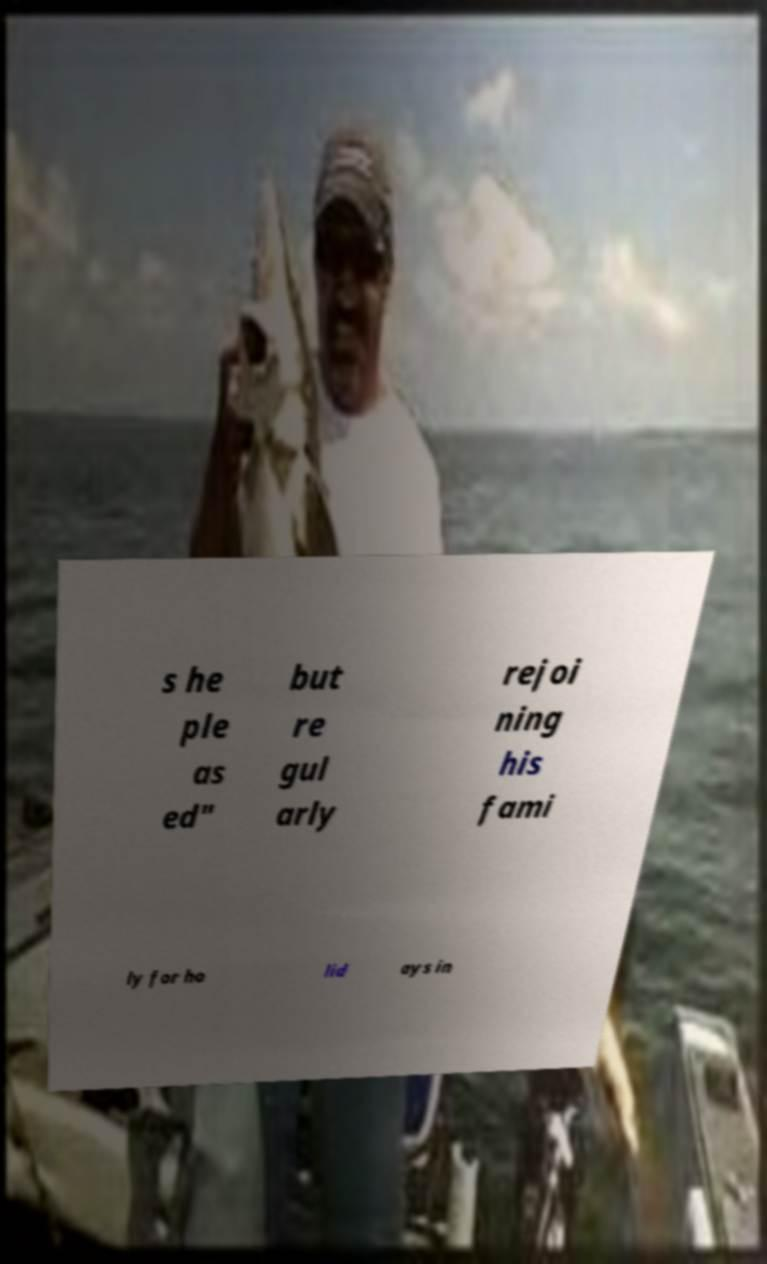Could you assist in decoding the text presented in this image and type it out clearly? s he ple as ed" but re gul arly rejoi ning his fami ly for ho lid ays in 